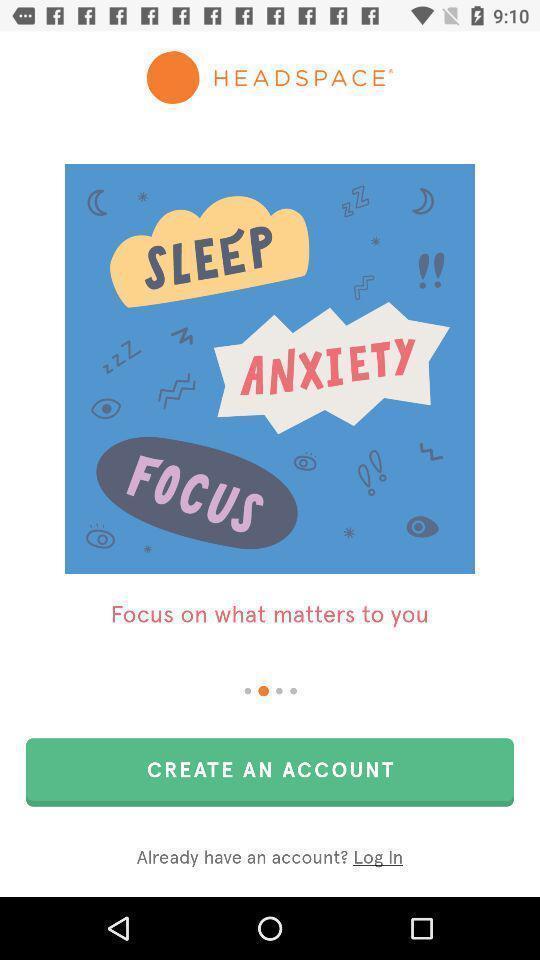Summarize the information in this screenshot. Welcome page to create an account for meditating app. 